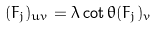<formula> <loc_0><loc_0><loc_500><loc_500>( F _ { j } ) _ { u v } = \lambda \cot \theta ( F _ { j } ) _ { v }</formula> 